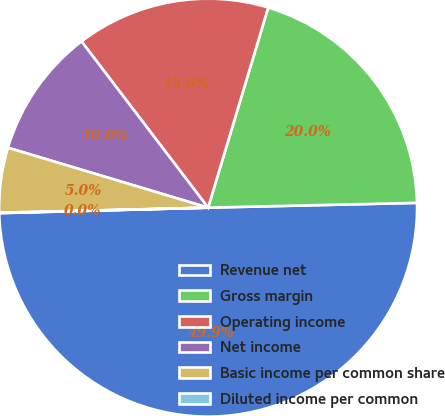Convert chart to OTSL. <chart><loc_0><loc_0><loc_500><loc_500><pie_chart><fcel>Revenue net<fcel>Gross margin<fcel>Operating income<fcel>Net income<fcel>Basic income per common share<fcel>Diluted income per common<nl><fcel>49.94%<fcel>19.99%<fcel>15.0%<fcel>10.01%<fcel>5.02%<fcel>0.03%<nl></chart> 